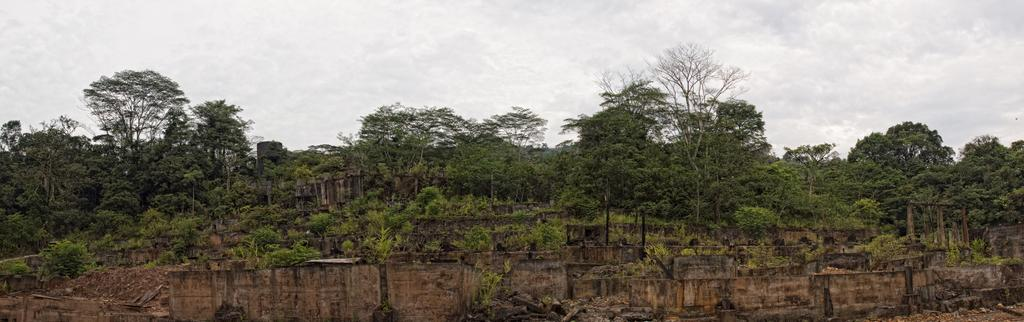What type of vegetation can be seen in the image? There are trees in the image. What structure is visible in the image? There is a wall in the image. What is visible in the background of the image? The sky is visible in the image. What type of cushion is being used to control the trees in the image? There is no cushion or control mechanism present in the image; it features trees and a wall. Can you describe the bite marks on the trees in the image? There are no bite marks visible on the trees in the image. 